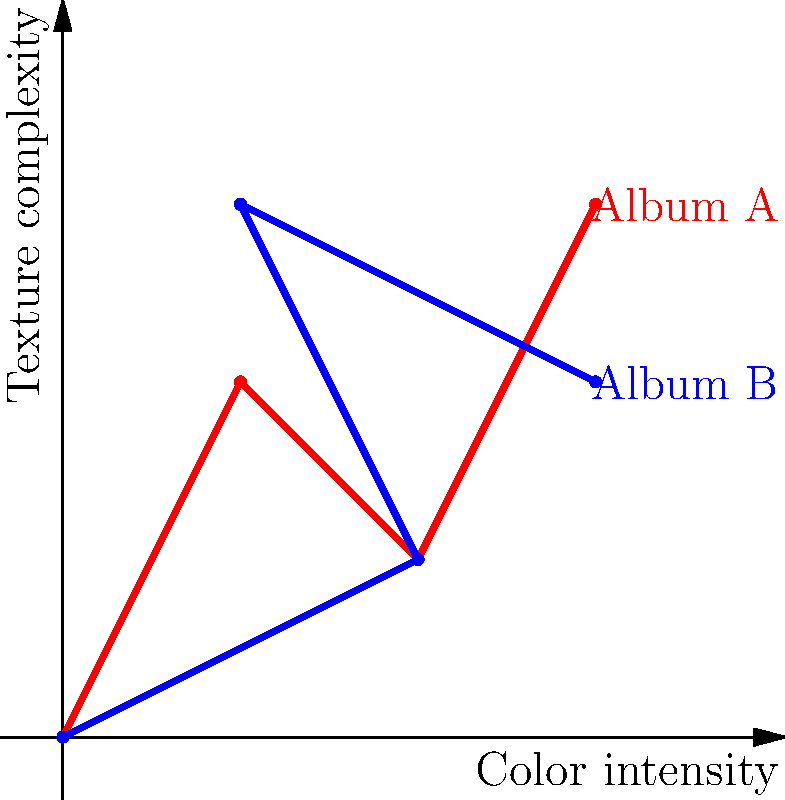The graph shows feature vectors for two Linkin Park album covers: Album A (red) and Album B (blue). Each point represents a combination of color intensity (x-axis) and texture complexity (y-axis). Calculate the cosine similarity between these two album covers using the dot product method. Round your answer to two decimal places. To calculate the cosine similarity using the dot product method, we'll follow these steps:

1. Represent each album cover as a vector:
   Album A: $\mathbf{a} = (1, 2, 2, 1, 3, 3)$
   Album B: $\mathbf{b} = (2, 1, 1, 3, 3, 2)$

2. Calculate the dot product of the two vectors:
   $\mathbf{a} \cdot \mathbf{b} = (1 \times 2) + (2 \times 1) + (2 \times 1) + (1 \times 3) + (3 \times 3) + (3 \times 2) = 2 + 2 + 2 + 3 + 9 + 6 = 24$

3. Calculate the magnitudes of each vector:
   $\|\mathbf{a}\| = \sqrt{1^2 + 2^2 + 2^2 + 1^2 + 3^2 + 3^2} = \sqrt{28}$
   $\|\mathbf{b}\| = \sqrt{2^2 + 1^2 + 1^2 + 3^2 + 3^2 + 2^2} = \sqrt{28}$

4. Apply the cosine similarity formula:
   $\cos \theta = \frac{\mathbf{a} \cdot \mathbf{b}}{\|\mathbf{a}\| \|\mathbf{b}\|} = \frac{24}{\sqrt{28} \sqrt{28}} = \frac{24}{28} = 0.8571$

5. Round the result to two decimal places:
   $0.86$

The cosine similarity ranges from -1 to 1, where 1 indicates perfect similarity. A value of 0.86 suggests a high degree of similarity between the two album covers.
Answer: 0.86 